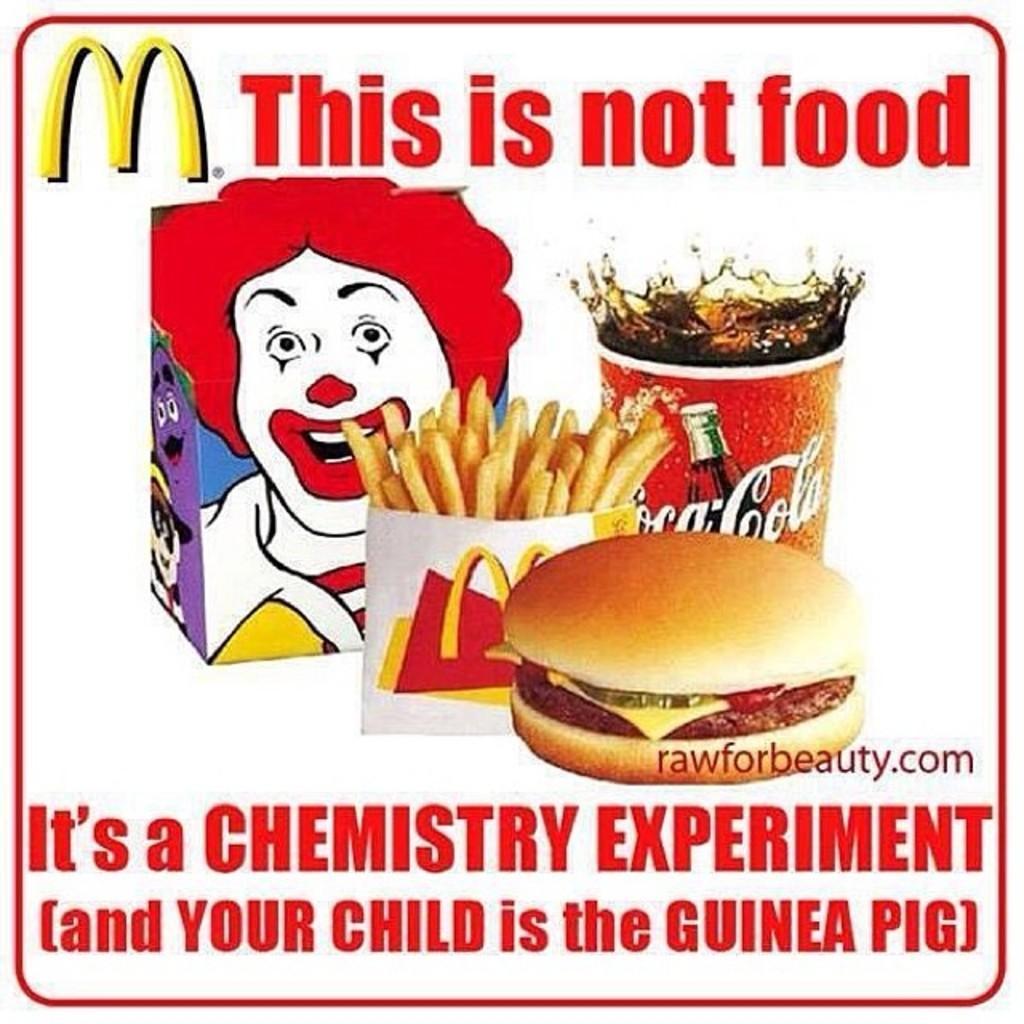Could you give a brief overview of what you see in this image? In this image we can see a poster. There is something written on this. Also there is a burger, glass with a drink, french fries in a packet. Also there is an animated image. 